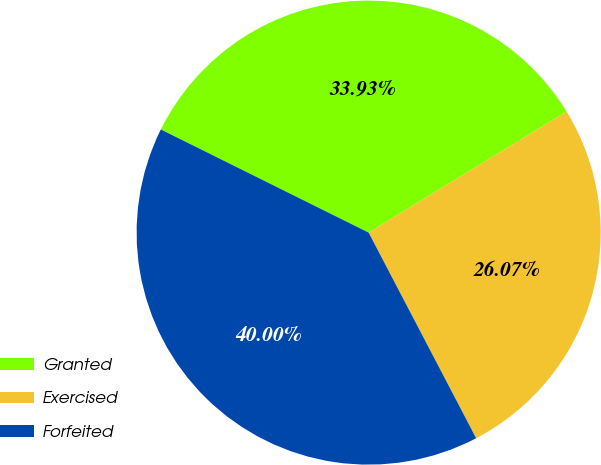<chart> <loc_0><loc_0><loc_500><loc_500><pie_chart><fcel>Granted<fcel>Exercised<fcel>Forfeited<nl><fcel>33.93%<fcel>26.07%<fcel>40.0%<nl></chart> 